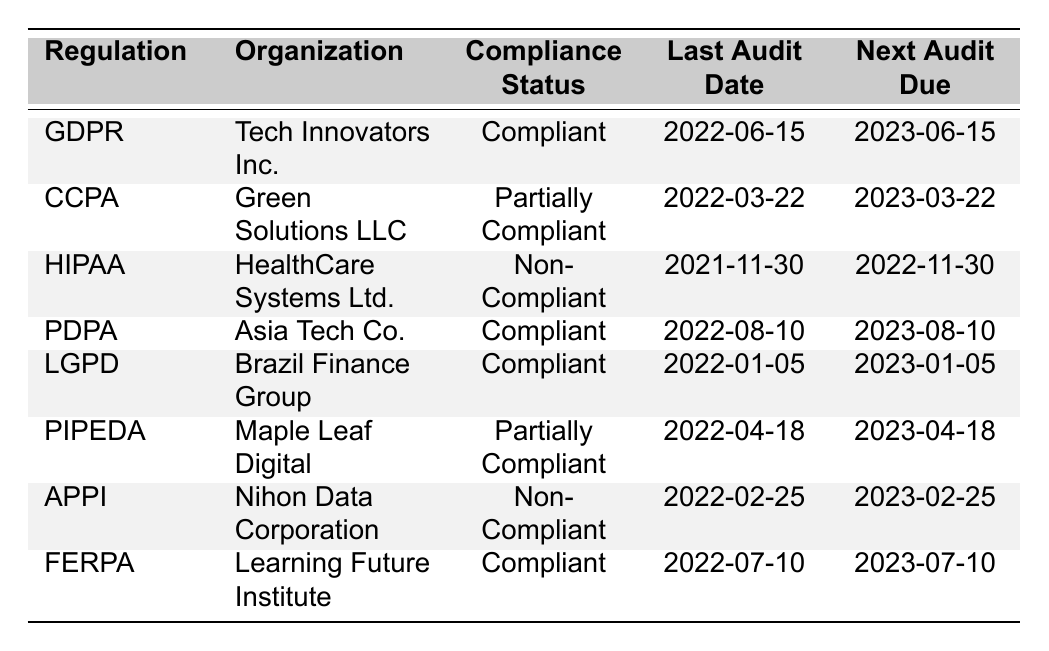What is the compliance status of Tech Innovators Inc. under GDPR? The table indicates that Tech Innovators Inc. has a compliance status of "Compliant" under GDPR.
Answer: Compliant When is the next audit due for Green Solutions LLC? According to the table, the next audit for Green Solutions LLC is due on 2023-03-22.
Answer: 2023-03-22 Which organization has a non-compliance status for HIPAA? The table states that HealthCare Systems Ltd. has a non-compliance status for HIPAA.
Answer: HealthCare Systems Ltd How many organizations are fully compliant with their respective regulations? The table shows that there are four organizations (Tech Innovators Inc., Asia Tech Co., Brazil Finance Group, and Learning Future Institute) that are compliant with their regulations.
Answer: 4 Is Learning Future Institute compliant with FERPA? The table indicates that Learning Future Institute is indeed compliant with FERPA since it states a compliance status of "Compliant."
Answer: Yes How many organizations have their next audit due in 2023? Counting the entries in the table, there are six organizations listed that have their next audit due in 2023 (Tech Innovators Inc., Green Solutions LLC, Asia Tech Co., Brazil Finance Group, Maple Leaf Digital, Learning Future Institute).
Answer: 6 What is the difference in days between the last audit dates of HIPAA and LGPD? The last audit date for HIPAA is 2021-11-30 and for LGPD it is 2022-01-05. The difference in days is 36 days (from Nov 30 to Jan 5 of the next year).
Answer: 36 days Name the organization that is partially compliant with CCPA and PIPEDA. The table specifies that Green Solutions LLC is partially compliant with CCPA, and Maple Leaf Digital is partially compliant with PIPEDA.
Answer: Green Solutions LLC and Maple Leaf Digital Which regulation has the last audit date closest to the end of 2022? The nearest last audit date to the end of 2022 is 2022-08-10 for PDPA, as it is the last audit date listed in the year 2022.
Answer: PDPA How many organizations are non-compliant? The table shows that there are two organizations listed as non-compliant with their regulations (HealthCare Systems Ltd. for HIPAA and Nihon Data Corporation for APPI).
Answer: 2 